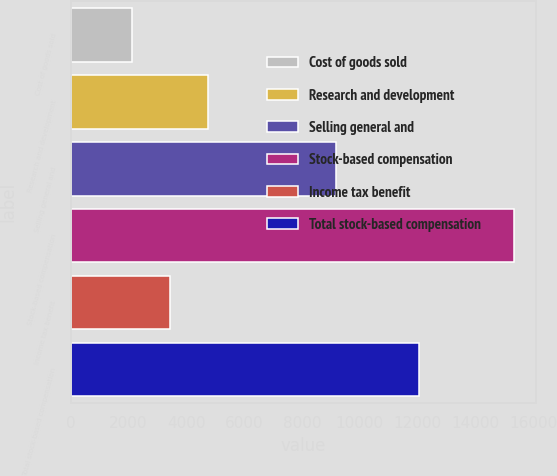Convert chart to OTSL. <chart><loc_0><loc_0><loc_500><loc_500><bar_chart><fcel>Cost of goods sold<fcel>Research and development<fcel>Selling general and<fcel>Stock-based compensation<fcel>Income tax benefit<fcel>Total stock-based compensation<nl><fcel>2124<fcel>4762.4<fcel>9159<fcel>15316<fcel>3443.2<fcel>12030<nl></chart> 